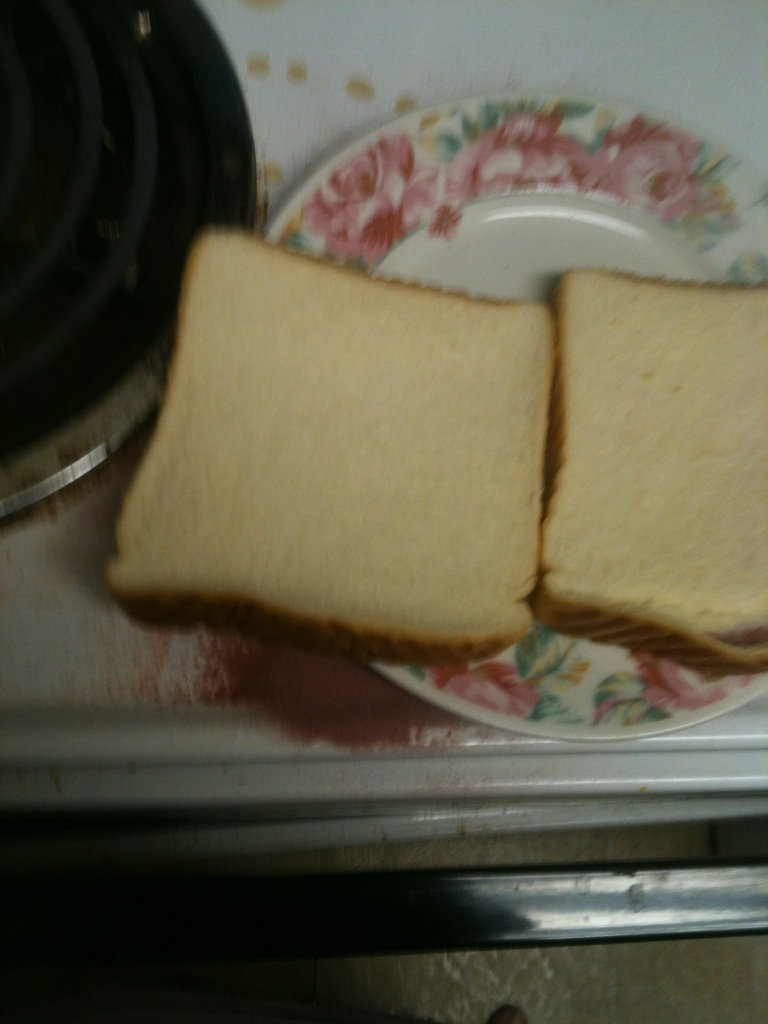Are you able to tell if there is any mold on the bread? from Vizwiz no mold 